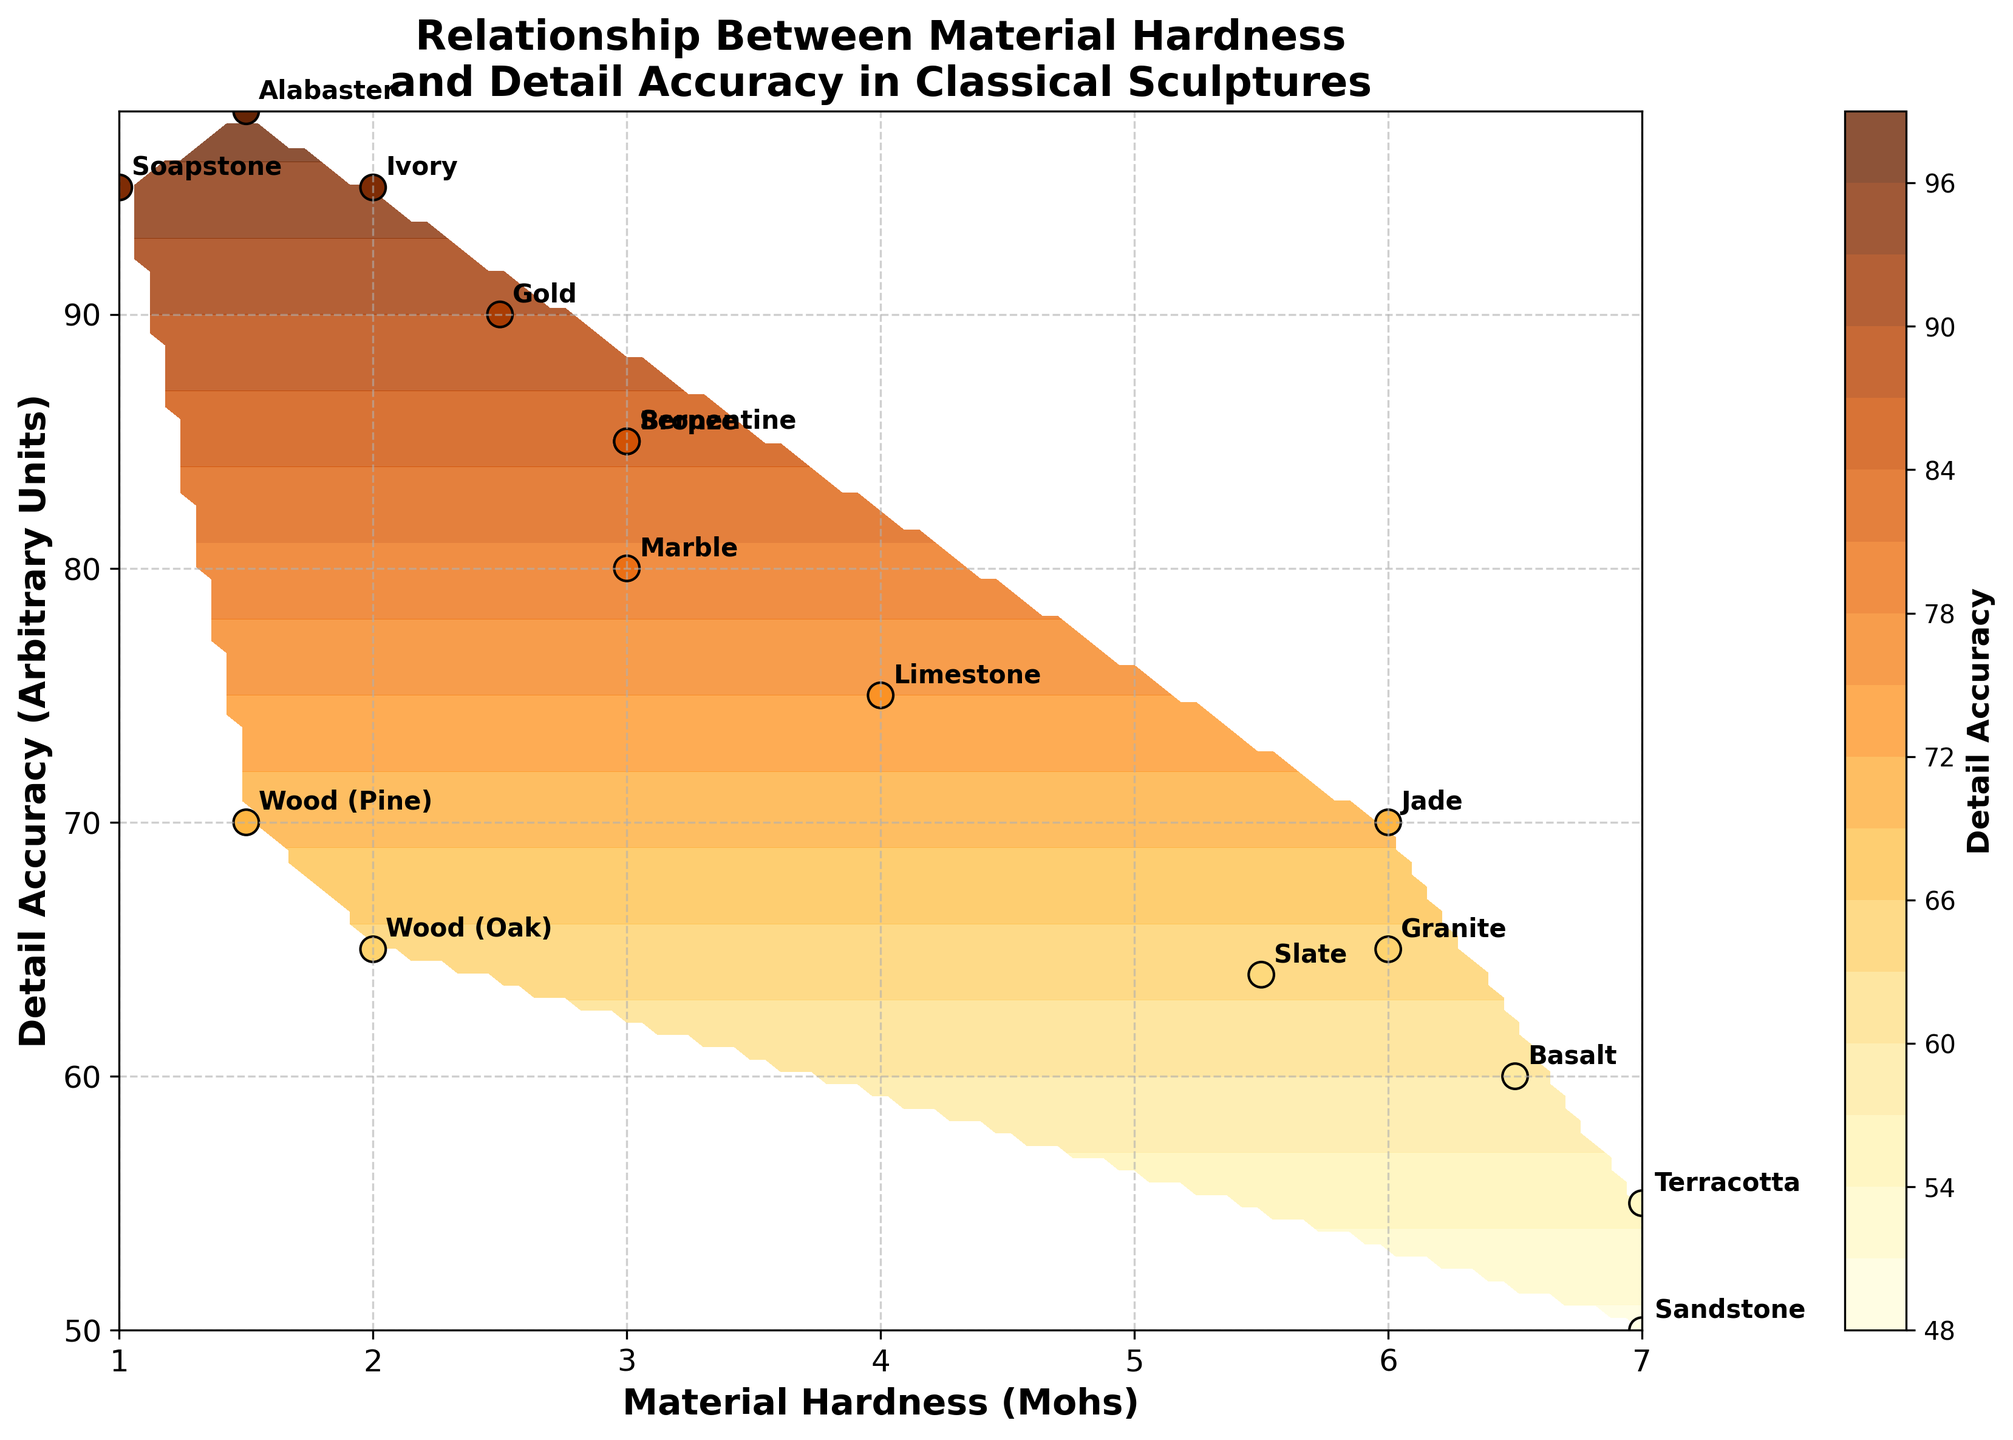What is the title of the figure? The title is typically found at the top of the figure, and it is meant to describe the main purpose or content of the plot.
Answer: Relationship Between Material Hardness and Detail Accuracy in Classical Sculptures What material has the highest detail accuracy? By looking at the scatter points and the annotations, the material with the highest detail accuracy should be identified.
Answer: Alabaster How is the x-axis labeled? The x-axis label describes what the horizontal axis represents in the plot.
Answer: Material Hardness (Mohs) Which material has a hardness of 7 on the Mohs scale? Find the scatter points and annotations at the position where the x-axis is 7.0.
Answer: Sandstone and Terracotta What are the two materials with the lowest hardness, and what are their detail accuracy values? Identify the scatter points corresponding to the lowest hardness values and read the corresponding y-axis values.
Answer: Alabaster (98) and Soapstone (95) What is the range of detail accuracy in the figure? Find the minimum and maximum values on the y-axis.
Answer: 50 to 98 How does detail accuracy change with increasing material hardness? Observe the trend formed by the scatter points and the contour lines with respect to the x-axis.
Answer: Generally decreases Which material shows an unusual combination of high detail accuracy and intermediate hardness? Look for scatter points with high y-values and intermediate x-values, then check the annotations.
Answer: Serpentine Compare the detail accuracy of Marble and Granite. Find and compare the y-values (detail accuracy) corresponding to the annotations for Marble and Granite.
Answer: Marble (80), Granite (65) What is the hardness of the material that has the second-highest detail accuracy? Identify the scatter point with the second-highest y-value and note the corresponding x-value.
Answer: Soapstone (1) 